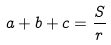<formula> <loc_0><loc_0><loc_500><loc_500>a + b + c = \frac { S } { r }</formula> 